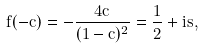Convert formula to latex. <formula><loc_0><loc_0><loc_500><loc_500>f ( - c ) = - \frac { 4 c } { ( 1 - c ) ^ { 2 } } = \frac { 1 } { 2 } + i s ,</formula> 